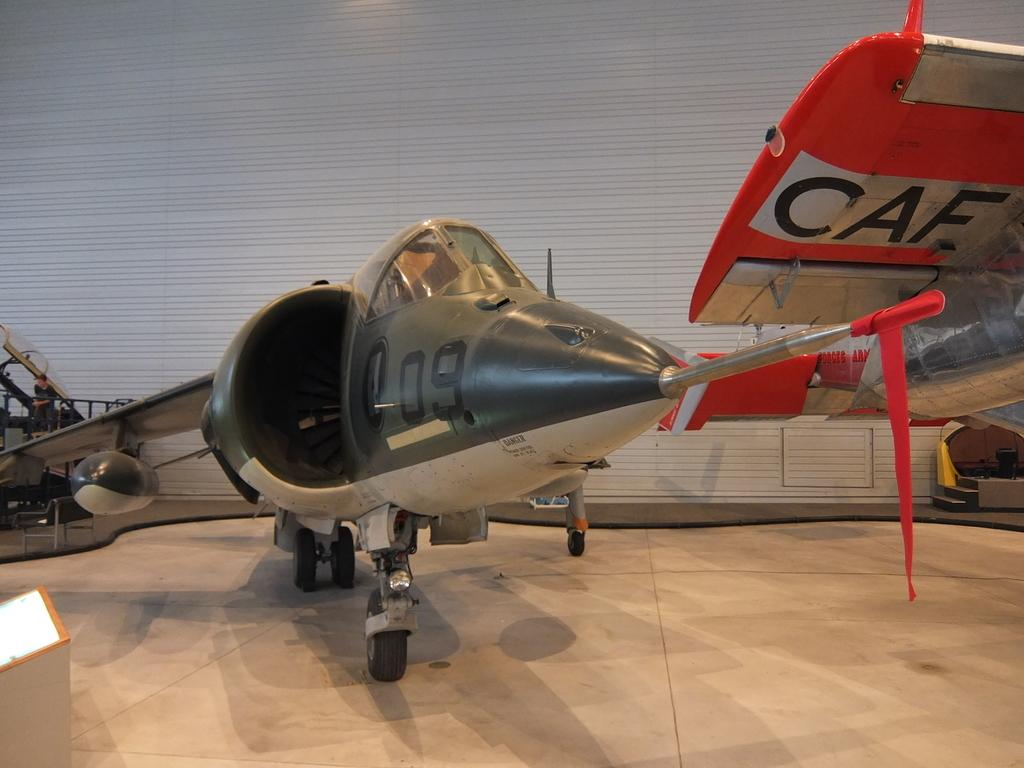<image>
Relay a brief, clear account of the picture shown. The underside of a plane's orange colored wing is marked with CAF. 